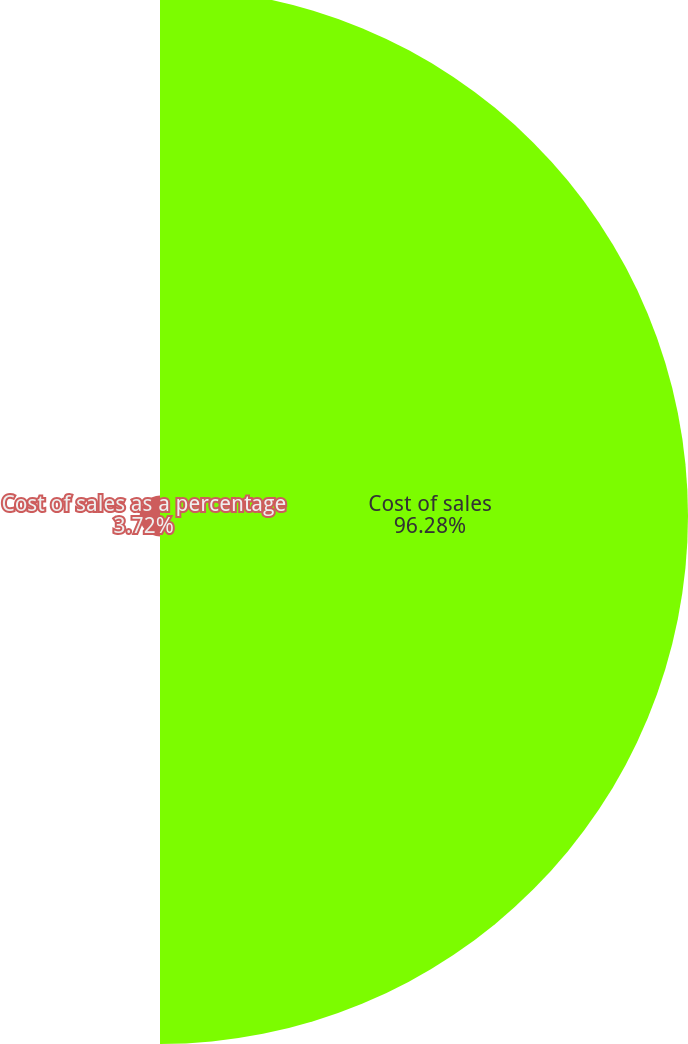Convert chart to OTSL. <chart><loc_0><loc_0><loc_500><loc_500><pie_chart><fcel>Cost of sales<fcel>Cost of sales as a percentage<nl><fcel>96.28%<fcel>3.72%<nl></chart> 